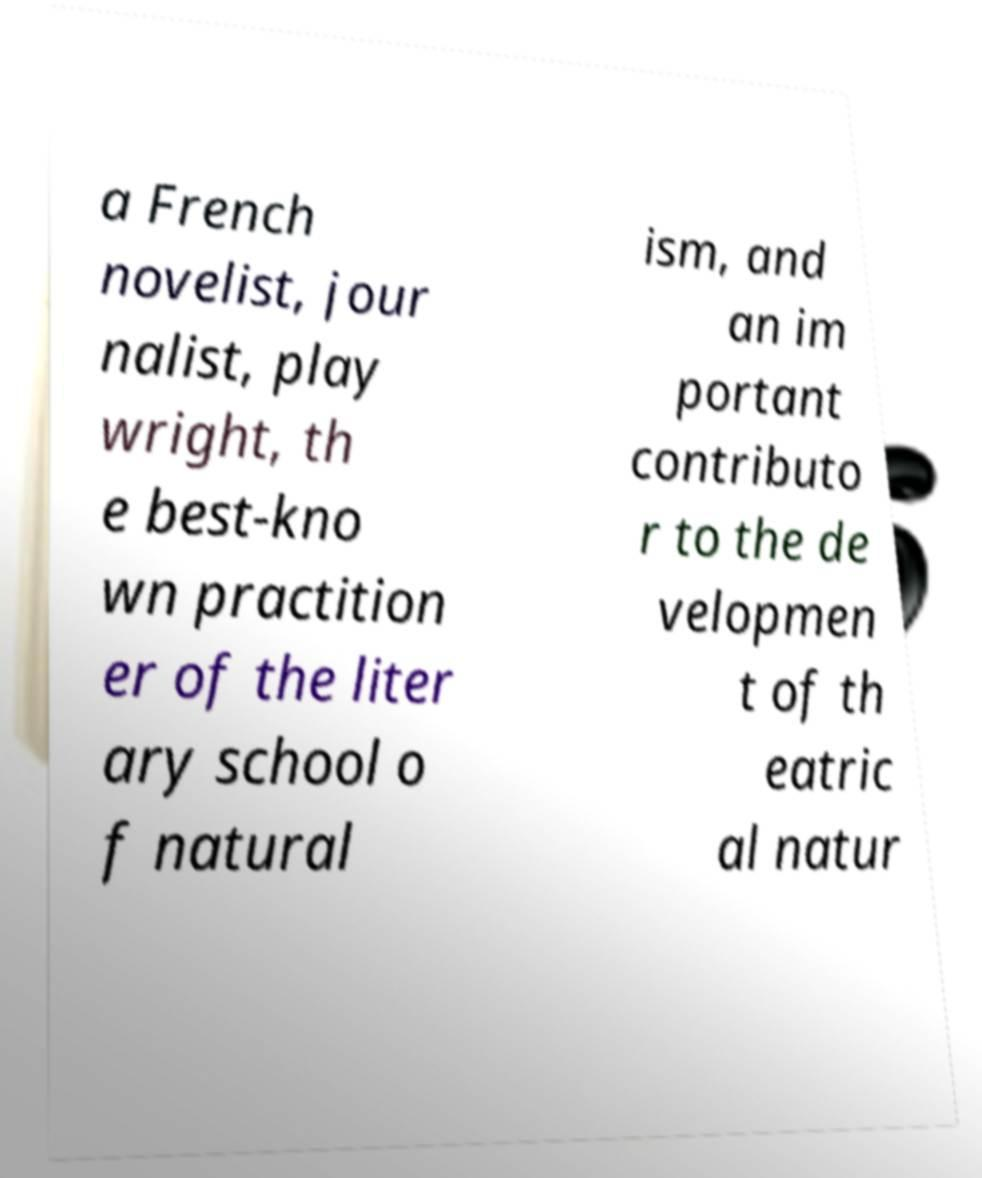I need the written content from this picture converted into text. Can you do that? a French novelist, jour nalist, play wright, th e best-kno wn practition er of the liter ary school o f natural ism, and an im portant contributo r to the de velopmen t of th eatric al natur 